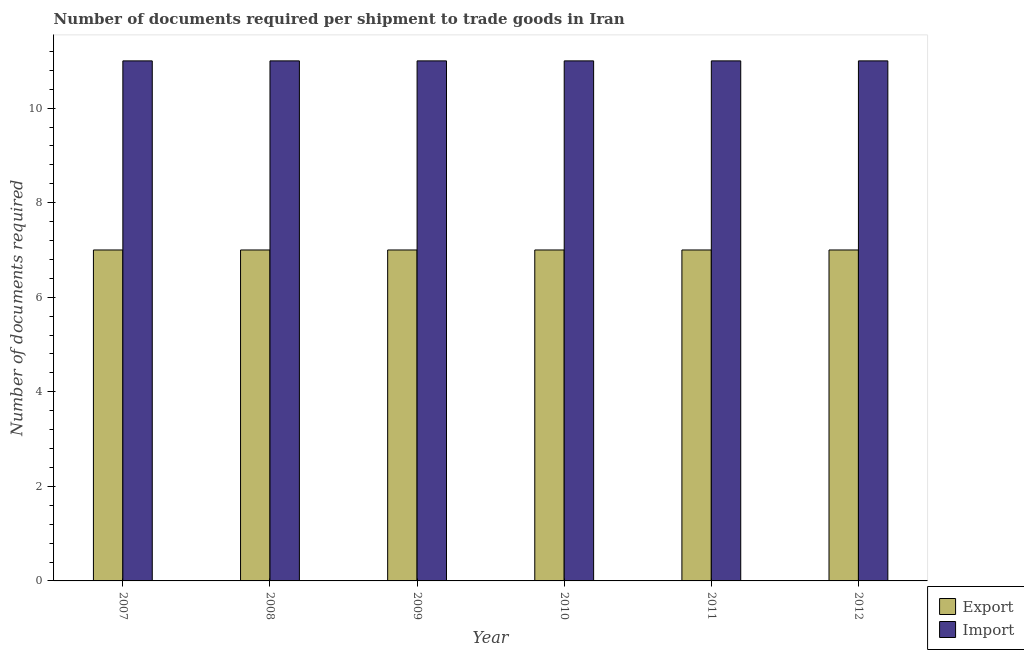Are the number of bars per tick equal to the number of legend labels?
Provide a short and direct response. Yes. How many bars are there on the 4th tick from the right?
Your response must be concise. 2. What is the label of the 2nd group of bars from the left?
Provide a succinct answer. 2008. What is the number of documents required to export goods in 2009?
Provide a short and direct response. 7. Across all years, what is the maximum number of documents required to export goods?
Provide a succinct answer. 7. Across all years, what is the minimum number of documents required to import goods?
Your answer should be very brief. 11. In which year was the number of documents required to export goods maximum?
Offer a very short reply. 2007. What is the total number of documents required to import goods in the graph?
Provide a short and direct response. 66. In the year 2011, what is the difference between the number of documents required to import goods and number of documents required to export goods?
Keep it short and to the point. 0. In how many years, is the number of documents required to export goods greater than 0.4?
Offer a very short reply. 6. What is the ratio of the number of documents required to import goods in 2007 to that in 2008?
Provide a short and direct response. 1. Is the number of documents required to export goods in 2007 less than that in 2008?
Your response must be concise. No. Is the difference between the number of documents required to import goods in 2009 and 2010 greater than the difference between the number of documents required to export goods in 2009 and 2010?
Your answer should be very brief. No. What is the difference between the highest and the second highest number of documents required to export goods?
Your answer should be very brief. 0. What is the difference between the highest and the lowest number of documents required to export goods?
Your answer should be very brief. 0. In how many years, is the number of documents required to import goods greater than the average number of documents required to import goods taken over all years?
Your answer should be compact. 0. What does the 1st bar from the left in 2011 represents?
Your response must be concise. Export. What does the 1st bar from the right in 2008 represents?
Ensure brevity in your answer.  Import. How many bars are there?
Ensure brevity in your answer.  12. What is the difference between two consecutive major ticks on the Y-axis?
Make the answer very short. 2. Does the graph contain any zero values?
Ensure brevity in your answer.  No. How many legend labels are there?
Offer a very short reply. 2. How are the legend labels stacked?
Your answer should be compact. Vertical. What is the title of the graph?
Provide a short and direct response. Number of documents required per shipment to trade goods in Iran. What is the label or title of the Y-axis?
Make the answer very short. Number of documents required. What is the Number of documents required in Import in 2008?
Offer a terse response. 11. What is the Number of documents required in Import in 2009?
Offer a very short reply. 11. What is the Number of documents required of Export in 2010?
Provide a short and direct response. 7. What is the Number of documents required in Import in 2010?
Offer a terse response. 11. What is the Number of documents required in Export in 2011?
Provide a short and direct response. 7. What is the Number of documents required of Import in 2011?
Your response must be concise. 11. What is the Number of documents required in Import in 2012?
Give a very brief answer. 11. Across all years, what is the maximum Number of documents required in Import?
Provide a succinct answer. 11. What is the total Number of documents required of Import in the graph?
Ensure brevity in your answer.  66. What is the difference between the Number of documents required of Export in 2007 and that in 2008?
Provide a short and direct response. 0. What is the difference between the Number of documents required of Import in 2007 and that in 2010?
Provide a succinct answer. 0. What is the difference between the Number of documents required in Export in 2007 and that in 2011?
Your answer should be very brief. 0. What is the difference between the Number of documents required in Export in 2007 and that in 2012?
Your answer should be very brief. 0. What is the difference between the Number of documents required of Import in 2008 and that in 2009?
Make the answer very short. 0. What is the difference between the Number of documents required of Export in 2008 and that in 2010?
Offer a terse response. 0. What is the difference between the Number of documents required of Export in 2008 and that in 2011?
Your response must be concise. 0. What is the difference between the Number of documents required in Import in 2008 and that in 2012?
Your answer should be very brief. 0. What is the difference between the Number of documents required of Export in 2009 and that in 2010?
Give a very brief answer. 0. What is the difference between the Number of documents required in Export in 2009 and that in 2011?
Offer a terse response. 0. What is the difference between the Number of documents required in Export in 2010 and that in 2011?
Your response must be concise. 0. What is the difference between the Number of documents required in Export in 2010 and that in 2012?
Keep it short and to the point. 0. What is the difference between the Number of documents required in Export in 2011 and that in 2012?
Give a very brief answer. 0. What is the difference between the Number of documents required of Export in 2007 and the Number of documents required of Import in 2009?
Ensure brevity in your answer.  -4. What is the difference between the Number of documents required of Export in 2007 and the Number of documents required of Import in 2012?
Give a very brief answer. -4. What is the difference between the Number of documents required in Export in 2008 and the Number of documents required in Import in 2010?
Keep it short and to the point. -4. What is the difference between the Number of documents required in Export in 2008 and the Number of documents required in Import in 2012?
Ensure brevity in your answer.  -4. What is the difference between the Number of documents required of Export in 2011 and the Number of documents required of Import in 2012?
Offer a terse response. -4. What is the average Number of documents required of Import per year?
Provide a succinct answer. 11. In the year 2007, what is the difference between the Number of documents required in Export and Number of documents required in Import?
Your response must be concise. -4. In the year 2011, what is the difference between the Number of documents required in Export and Number of documents required in Import?
Give a very brief answer. -4. What is the ratio of the Number of documents required in Export in 2007 to that in 2008?
Your response must be concise. 1. What is the ratio of the Number of documents required in Export in 2007 to that in 2009?
Your answer should be very brief. 1. What is the ratio of the Number of documents required of Export in 2007 to that in 2010?
Offer a very short reply. 1. What is the ratio of the Number of documents required in Import in 2007 to that in 2010?
Ensure brevity in your answer.  1. What is the ratio of the Number of documents required of Export in 2007 to that in 2011?
Provide a short and direct response. 1. What is the ratio of the Number of documents required in Export in 2007 to that in 2012?
Offer a terse response. 1. What is the ratio of the Number of documents required of Export in 2008 to that in 2010?
Your answer should be compact. 1. What is the ratio of the Number of documents required in Import in 2008 to that in 2010?
Give a very brief answer. 1. What is the ratio of the Number of documents required in Import in 2008 to that in 2011?
Give a very brief answer. 1. What is the ratio of the Number of documents required in Import in 2008 to that in 2012?
Ensure brevity in your answer.  1. What is the ratio of the Number of documents required of Import in 2009 to that in 2010?
Provide a succinct answer. 1. What is the ratio of the Number of documents required in Export in 2009 to that in 2011?
Your answer should be compact. 1. What is the ratio of the Number of documents required in Import in 2009 to that in 2012?
Provide a short and direct response. 1. What is the ratio of the Number of documents required in Export in 2010 to that in 2011?
Keep it short and to the point. 1. What is the ratio of the Number of documents required of Import in 2010 to that in 2011?
Provide a short and direct response. 1. What is the ratio of the Number of documents required of Import in 2011 to that in 2012?
Your answer should be very brief. 1. What is the difference between the highest and the lowest Number of documents required in Import?
Offer a terse response. 0. 